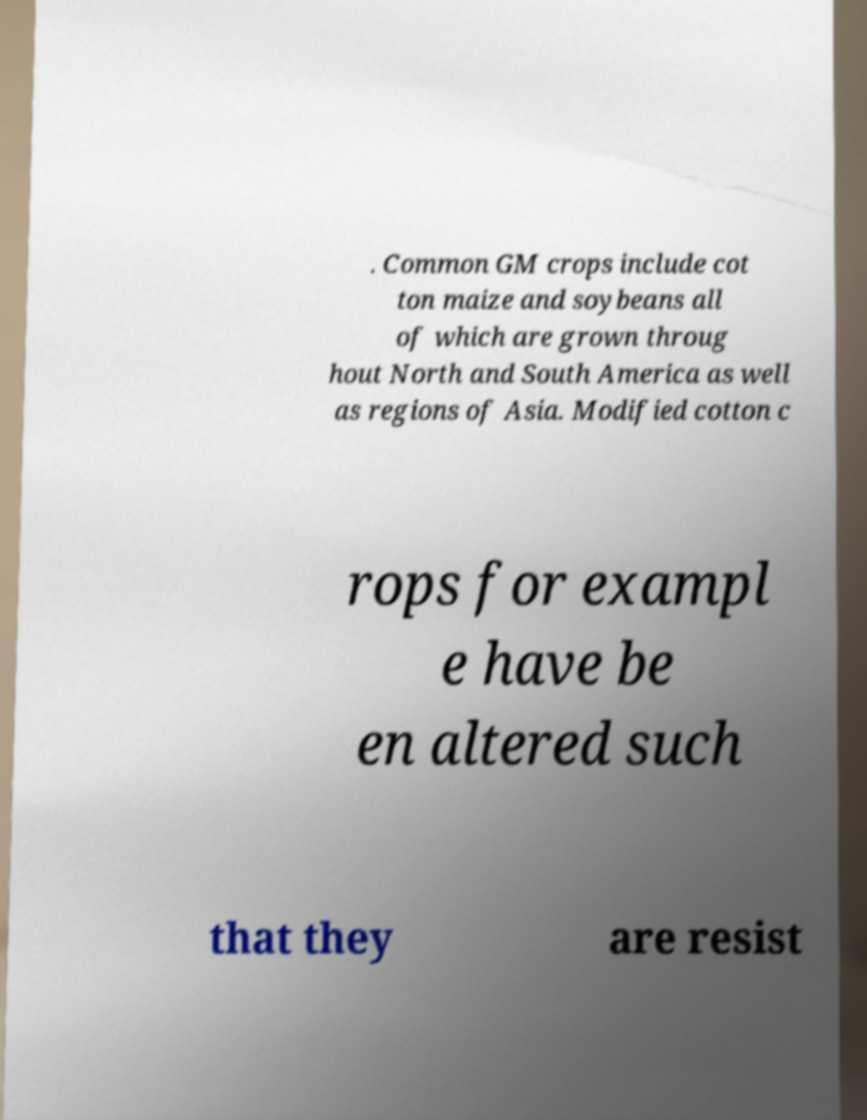Can you read and provide the text displayed in the image?This photo seems to have some interesting text. Can you extract and type it out for me? . Common GM crops include cot ton maize and soybeans all of which are grown throug hout North and South America as well as regions of Asia. Modified cotton c rops for exampl e have be en altered such that they are resist 